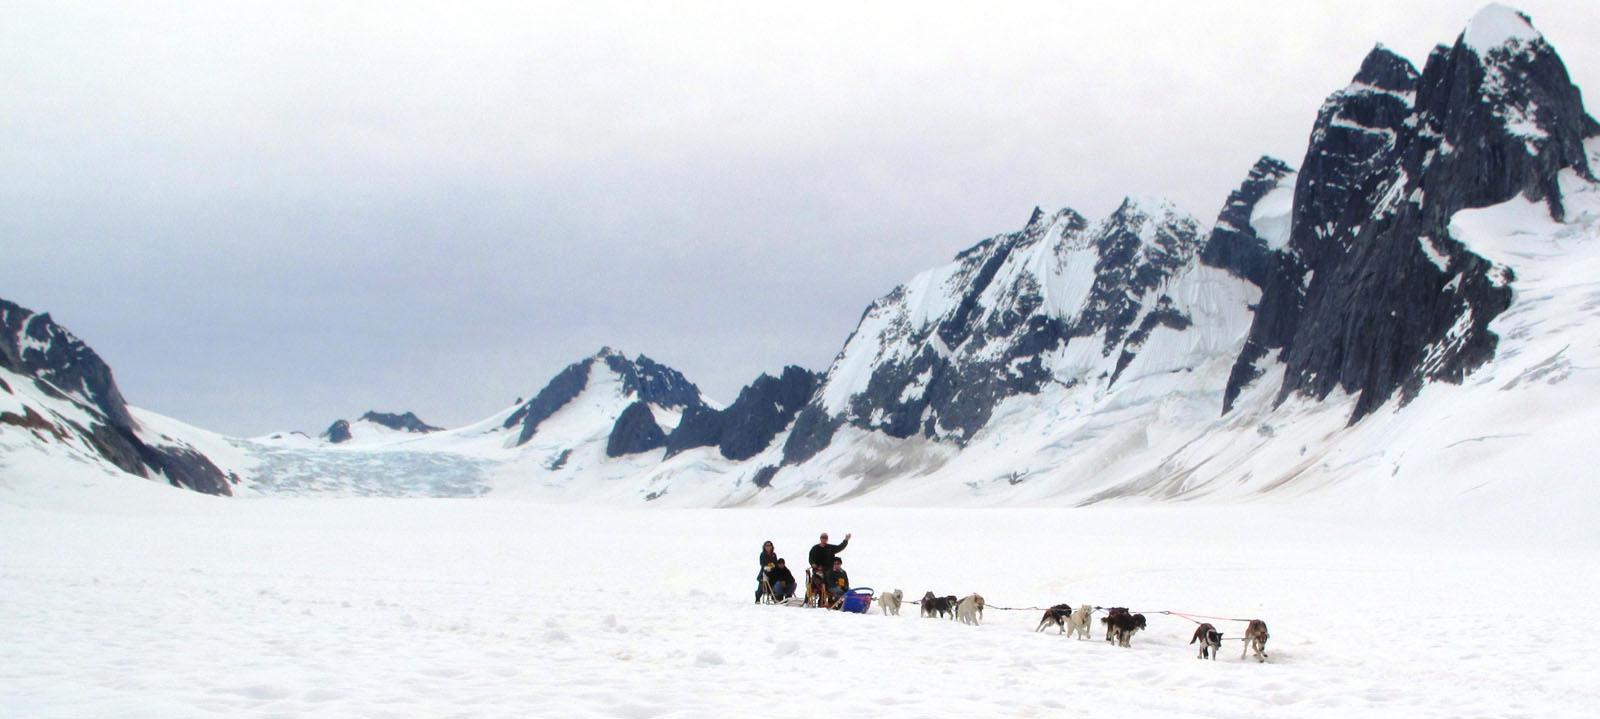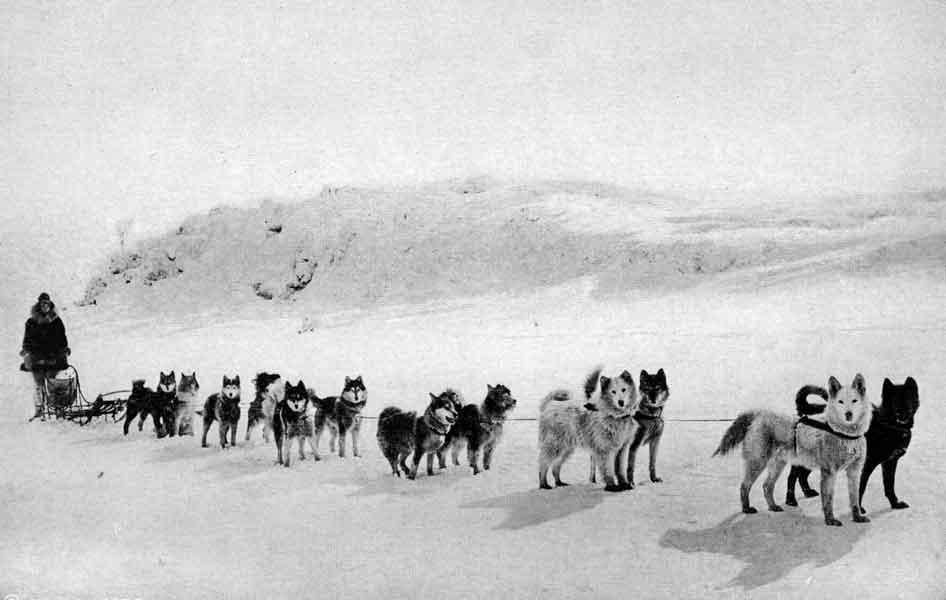The first image is the image on the left, the second image is the image on the right. For the images displayed, is the sentence "One of the images shows flat terrain with no trees behind the sled dogs." factually correct? Answer yes or no. No. The first image is the image on the left, the second image is the image on the right. Given the left and right images, does the statement "The lead dog of a sled team aimed leftward is reclining on the snow with both front paws extended and is gazing to the side." hold true? Answer yes or no. No. 